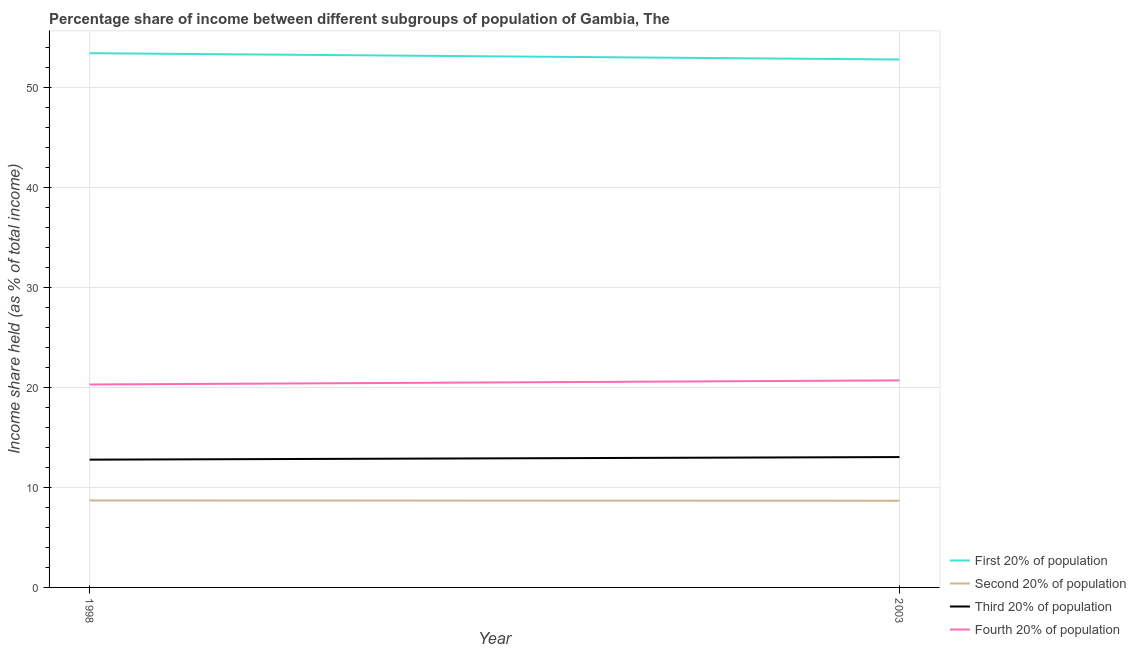What is the share of the income held by third 20% of the population in 1998?
Offer a terse response. 12.78. Across all years, what is the maximum share of the income held by fourth 20% of the population?
Provide a succinct answer. 20.71. Across all years, what is the minimum share of the income held by second 20% of the population?
Give a very brief answer. 8.67. What is the total share of the income held by second 20% of the population in the graph?
Make the answer very short. 17.37. What is the difference between the share of the income held by second 20% of the population in 1998 and that in 2003?
Your answer should be very brief. 0.03. What is the difference between the share of the income held by second 20% of the population in 1998 and the share of the income held by third 20% of the population in 2003?
Your answer should be compact. -4.34. What is the average share of the income held by second 20% of the population per year?
Offer a terse response. 8.68. In the year 2003, what is the difference between the share of the income held by second 20% of the population and share of the income held by fourth 20% of the population?
Your answer should be compact. -12.04. In how many years, is the share of the income held by second 20% of the population greater than 52 %?
Provide a short and direct response. 0. What is the ratio of the share of the income held by first 20% of the population in 1998 to that in 2003?
Provide a succinct answer. 1.01. Is the share of the income held by third 20% of the population in 1998 less than that in 2003?
Provide a succinct answer. Yes. Is the share of the income held by fourth 20% of the population strictly greater than the share of the income held by third 20% of the population over the years?
Offer a terse response. Yes. Is the share of the income held by fourth 20% of the population strictly less than the share of the income held by second 20% of the population over the years?
Give a very brief answer. No. How many lines are there?
Keep it short and to the point. 4. How many years are there in the graph?
Your response must be concise. 2. Are the values on the major ticks of Y-axis written in scientific E-notation?
Your answer should be compact. No. Does the graph contain grids?
Ensure brevity in your answer.  Yes. How many legend labels are there?
Make the answer very short. 4. How are the legend labels stacked?
Offer a terse response. Vertical. What is the title of the graph?
Offer a terse response. Percentage share of income between different subgroups of population of Gambia, The. What is the label or title of the X-axis?
Your response must be concise. Year. What is the label or title of the Y-axis?
Offer a terse response. Income share held (as % of total income). What is the Income share held (as % of total income) in First 20% of population in 1998?
Your answer should be very brief. 53.44. What is the Income share held (as % of total income) of Second 20% of population in 1998?
Provide a short and direct response. 8.7. What is the Income share held (as % of total income) in Third 20% of population in 1998?
Keep it short and to the point. 12.78. What is the Income share held (as % of total income) in Fourth 20% of population in 1998?
Provide a succinct answer. 20.3. What is the Income share held (as % of total income) of First 20% of population in 2003?
Keep it short and to the point. 52.81. What is the Income share held (as % of total income) of Second 20% of population in 2003?
Offer a very short reply. 8.67. What is the Income share held (as % of total income) of Third 20% of population in 2003?
Your response must be concise. 13.04. What is the Income share held (as % of total income) in Fourth 20% of population in 2003?
Offer a terse response. 20.71. Across all years, what is the maximum Income share held (as % of total income) of First 20% of population?
Keep it short and to the point. 53.44. Across all years, what is the maximum Income share held (as % of total income) of Third 20% of population?
Offer a terse response. 13.04. Across all years, what is the maximum Income share held (as % of total income) of Fourth 20% of population?
Ensure brevity in your answer.  20.71. Across all years, what is the minimum Income share held (as % of total income) of First 20% of population?
Keep it short and to the point. 52.81. Across all years, what is the minimum Income share held (as % of total income) of Second 20% of population?
Keep it short and to the point. 8.67. Across all years, what is the minimum Income share held (as % of total income) of Third 20% of population?
Make the answer very short. 12.78. Across all years, what is the minimum Income share held (as % of total income) of Fourth 20% of population?
Your answer should be very brief. 20.3. What is the total Income share held (as % of total income) in First 20% of population in the graph?
Keep it short and to the point. 106.25. What is the total Income share held (as % of total income) in Second 20% of population in the graph?
Offer a terse response. 17.37. What is the total Income share held (as % of total income) of Third 20% of population in the graph?
Your answer should be very brief. 25.82. What is the total Income share held (as % of total income) in Fourth 20% of population in the graph?
Give a very brief answer. 41.01. What is the difference between the Income share held (as % of total income) of First 20% of population in 1998 and that in 2003?
Your response must be concise. 0.63. What is the difference between the Income share held (as % of total income) of Third 20% of population in 1998 and that in 2003?
Offer a terse response. -0.26. What is the difference between the Income share held (as % of total income) in Fourth 20% of population in 1998 and that in 2003?
Offer a very short reply. -0.41. What is the difference between the Income share held (as % of total income) of First 20% of population in 1998 and the Income share held (as % of total income) of Second 20% of population in 2003?
Provide a succinct answer. 44.77. What is the difference between the Income share held (as % of total income) of First 20% of population in 1998 and the Income share held (as % of total income) of Third 20% of population in 2003?
Your response must be concise. 40.4. What is the difference between the Income share held (as % of total income) in First 20% of population in 1998 and the Income share held (as % of total income) in Fourth 20% of population in 2003?
Give a very brief answer. 32.73. What is the difference between the Income share held (as % of total income) of Second 20% of population in 1998 and the Income share held (as % of total income) of Third 20% of population in 2003?
Keep it short and to the point. -4.34. What is the difference between the Income share held (as % of total income) of Second 20% of population in 1998 and the Income share held (as % of total income) of Fourth 20% of population in 2003?
Ensure brevity in your answer.  -12.01. What is the difference between the Income share held (as % of total income) of Third 20% of population in 1998 and the Income share held (as % of total income) of Fourth 20% of population in 2003?
Your answer should be compact. -7.93. What is the average Income share held (as % of total income) of First 20% of population per year?
Provide a succinct answer. 53.12. What is the average Income share held (as % of total income) in Second 20% of population per year?
Your answer should be compact. 8.69. What is the average Income share held (as % of total income) of Third 20% of population per year?
Make the answer very short. 12.91. What is the average Income share held (as % of total income) in Fourth 20% of population per year?
Your answer should be compact. 20.5. In the year 1998, what is the difference between the Income share held (as % of total income) of First 20% of population and Income share held (as % of total income) of Second 20% of population?
Keep it short and to the point. 44.74. In the year 1998, what is the difference between the Income share held (as % of total income) of First 20% of population and Income share held (as % of total income) of Third 20% of population?
Offer a terse response. 40.66. In the year 1998, what is the difference between the Income share held (as % of total income) in First 20% of population and Income share held (as % of total income) in Fourth 20% of population?
Keep it short and to the point. 33.14. In the year 1998, what is the difference between the Income share held (as % of total income) of Second 20% of population and Income share held (as % of total income) of Third 20% of population?
Your response must be concise. -4.08. In the year 1998, what is the difference between the Income share held (as % of total income) in Second 20% of population and Income share held (as % of total income) in Fourth 20% of population?
Offer a very short reply. -11.6. In the year 1998, what is the difference between the Income share held (as % of total income) in Third 20% of population and Income share held (as % of total income) in Fourth 20% of population?
Provide a short and direct response. -7.52. In the year 2003, what is the difference between the Income share held (as % of total income) in First 20% of population and Income share held (as % of total income) in Second 20% of population?
Make the answer very short. 44.14. In the year 2003, what is the difference between the Income share held (as % of total income) in First 20% of population and Income share held (as % of total income) in Third 20% of population?
Keep it short and to the point. 39.77. In the year 2003, what is the difference between the Income share held (as % of total income) of First 20% of population and Income share held (as % of total income) of Fourth 20% of population?
Give a very brief answer. 32.1. In the year 2003, what is the difference between the Income share held (as % of total income) in Second 20% of population and Income share held (as % of total income) in Third 20% of population?
Offer a very short reply. -4.37. In the year 2003, what is the difference between the Income share held (as % of total income) of Second 20% of population and Income share held (as % of total income) of Fourth 20% of population?
Your answer should be compact. -12.04. In the year 2003, what is the difference between the Income share held (as % of total income) of Third 20% of population and Income share held (as % of total income) of Fourth 20% of population?
Offer a terse response. -7.67. What is the ratio of the Income share held (as % of total income) of First 20% of population in 1998 to that in 2003?
Offer a very short reply. 1.01. What is the ratio of the Income share held (as % of total income) in Third 20% of population in 1998 to that in 2003?
Your answer should be very brief. 0.98. What is the ratio of the Income share held (as % of total income) of Fourth 20% of population in 1998 to that in 2003?
Ensure brevity in your answer.  0.98. What is the difference between the highest and the second highest Income share held (as % of total income) in First 20% of population?
Your answer should be very brief. 0.63. What is the difference between the highest and the second highest Income share held (as % of total income) in Second 20% of population?
Your answer should be very brief. 0.03. What is the difference between the highest and the second highest Income share held (as % of total income) in Third 20% of population?
Make the answer very short. 0.26. What is the difference between the highest and the second highest Income share held (as % of total income) of Fourth 20% of population?
Your response must be concise. 0.41. What is the difference between the highest and the lowest Income share held (as % of total income) of First 20% of population?
Give a very brief answer. 0.63. What is the difference between the highest and the lowest Income share held (as % of total income) of Third 20% of population?
Keep it short and to the point. 0.26. What is the difference between the highest and the lowest Income share held (as % of total income) in Fourth 20% of population?
Keep it short and to the point. 0.41. 